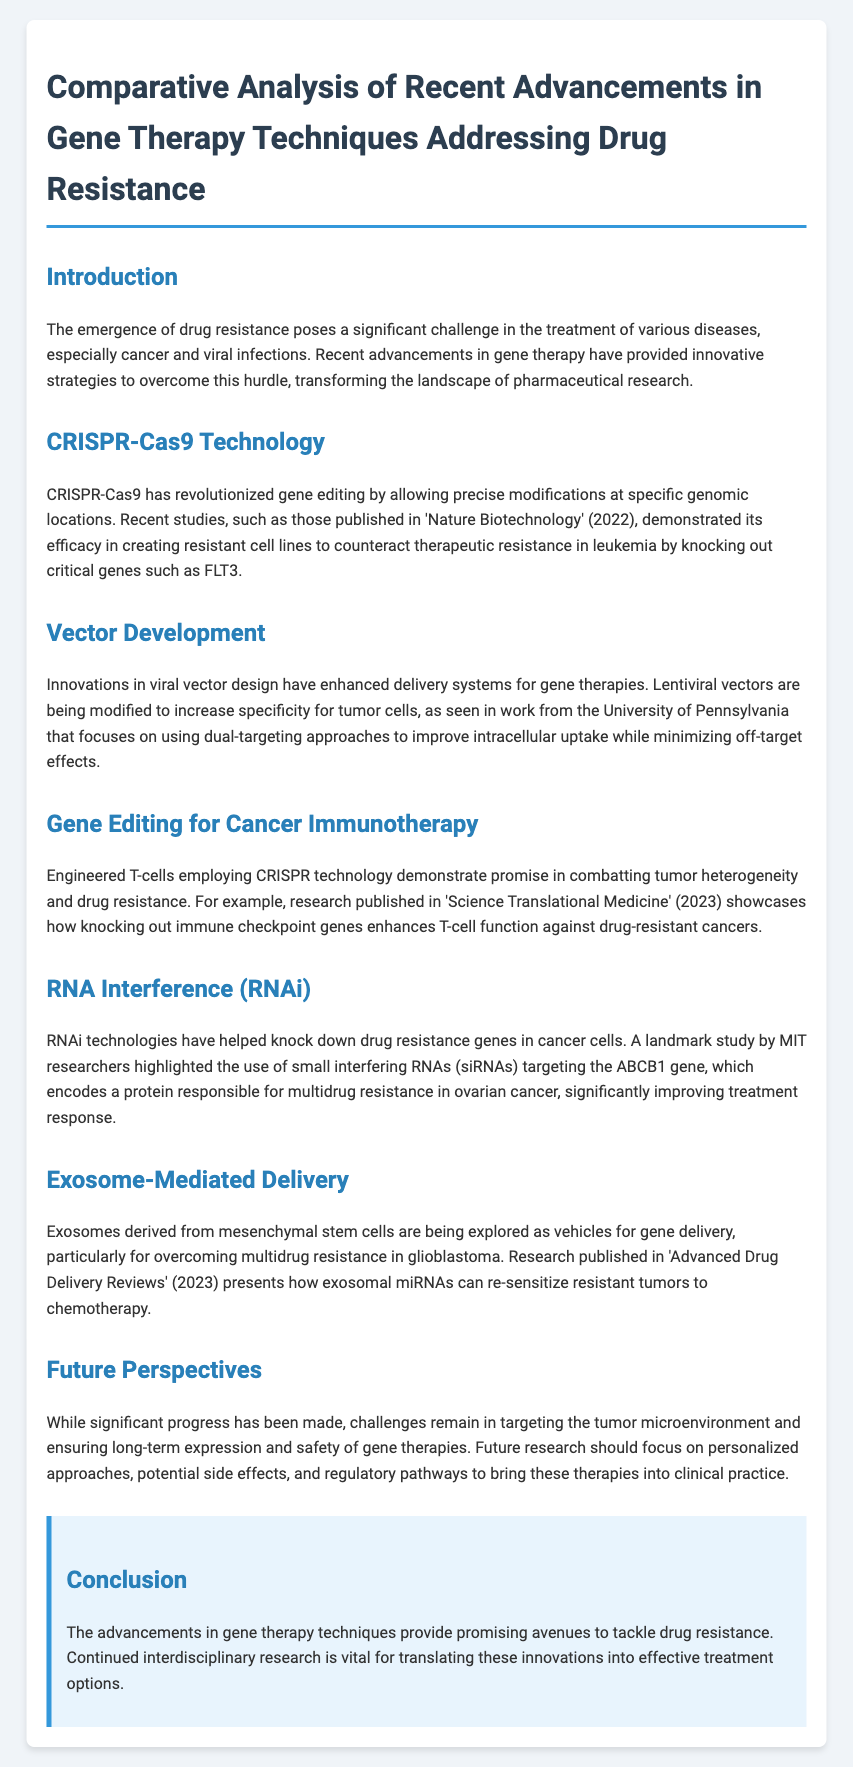what is the challenge posed by drug resistance? The document states that drug resistance poses a significant challenge in the treatment of various diseases, especially cancer and viral infections.
Answer: significant challenge which gene editing technology is mentioned? The document mentions CRISPR-Cas9 technology as a significant advancement in gene editing.
Answer: CRISPR-Cas9 who conducted a study on ABCB1 gene targeting? The document highlights a landmark study conducted by MIT researchers on targeting the ABCB1 gene in cancer cells.
Answer: MIT researchers what is the year of the research published in 'Science Translational Medicine'? The document references research published in 'Science Translational Medicine' in the year 2023.
Answer: 2023 what delivery system is enhanced for gene therapies? The document discusses innovations in viral vector design as enhancements for gene therapy delivery systems.
Answer: viral vector design how do engineered T-cells combat drug resistance? The document explains that engineered T-cells employing CRISPR technology combat drug resistance by knocking out immune checkpoint genes.
Answer: knocking out immune checkpoint genes what is a benefit of using exosomes in gene delivery? The document states that exosomes can re-sensitize resistant tumors to chemotherapy, overcoming multidrug resistance.
Answer: re-sensitize resistant tumors what aspect should future research focus on? According to the document, future research should focus on personalized approaches to gene therapies.
Answer: personalized approaches 